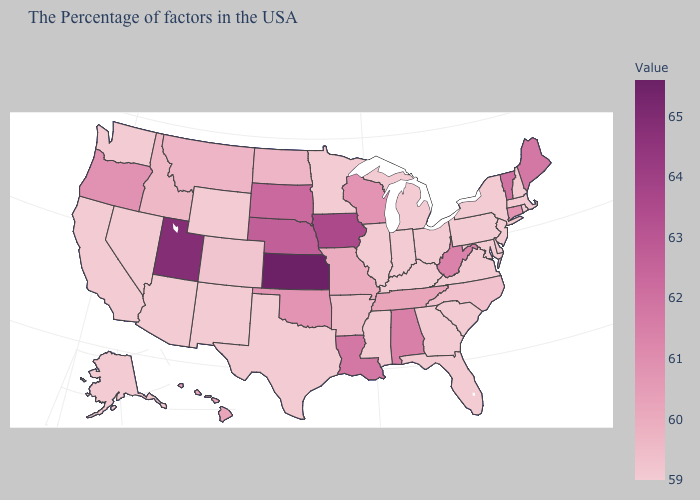Does Texas have the lowest value in the USA?
Keep it brief. Yes. Which states have the lowest value in the USA?
Answer briefly. Massachusetts, Rhode Island, New Hampshire, New York, New Jersey, Delaware, Maryland, Pennsylvania, Virginia, South Carolina, Ohio, Florida, Georgia, Michigan, Kentucky, Indiana, Illinois, Mississippi, Minnesota, Texas, Wyoming, New Mexico, Arizona, Nevada, California, Washington, Alaska. Does the map have missing data?
Give a very brief answer. No. Does Mississippi have the highest value in the USA?
Quick response, please. No. Does Louisiana have the highest value in the South?
Quick response, please. Yes. 